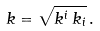Convert formula to latex. <formula><loc_0><loc_0><loc_500><loc_500>k = \sqrt { k ^ { i } \, k _ { i } } \, .</formula> 